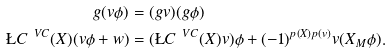Convert formula to latex. <formula><loc_0><loc_0><loc_500><loc_500>g ( v \phi ) & = ( g v ) ( g \phi ) \\ \L C ^ { \ V C } ( X ) ( v \phi + w ) & = ( \L C ^ { \ V C } ( X ) v ) \phi + ( - 1 ) ^ { p ( X ) p ( v ) } v ( X _ { M } \phi ) .</formula> 